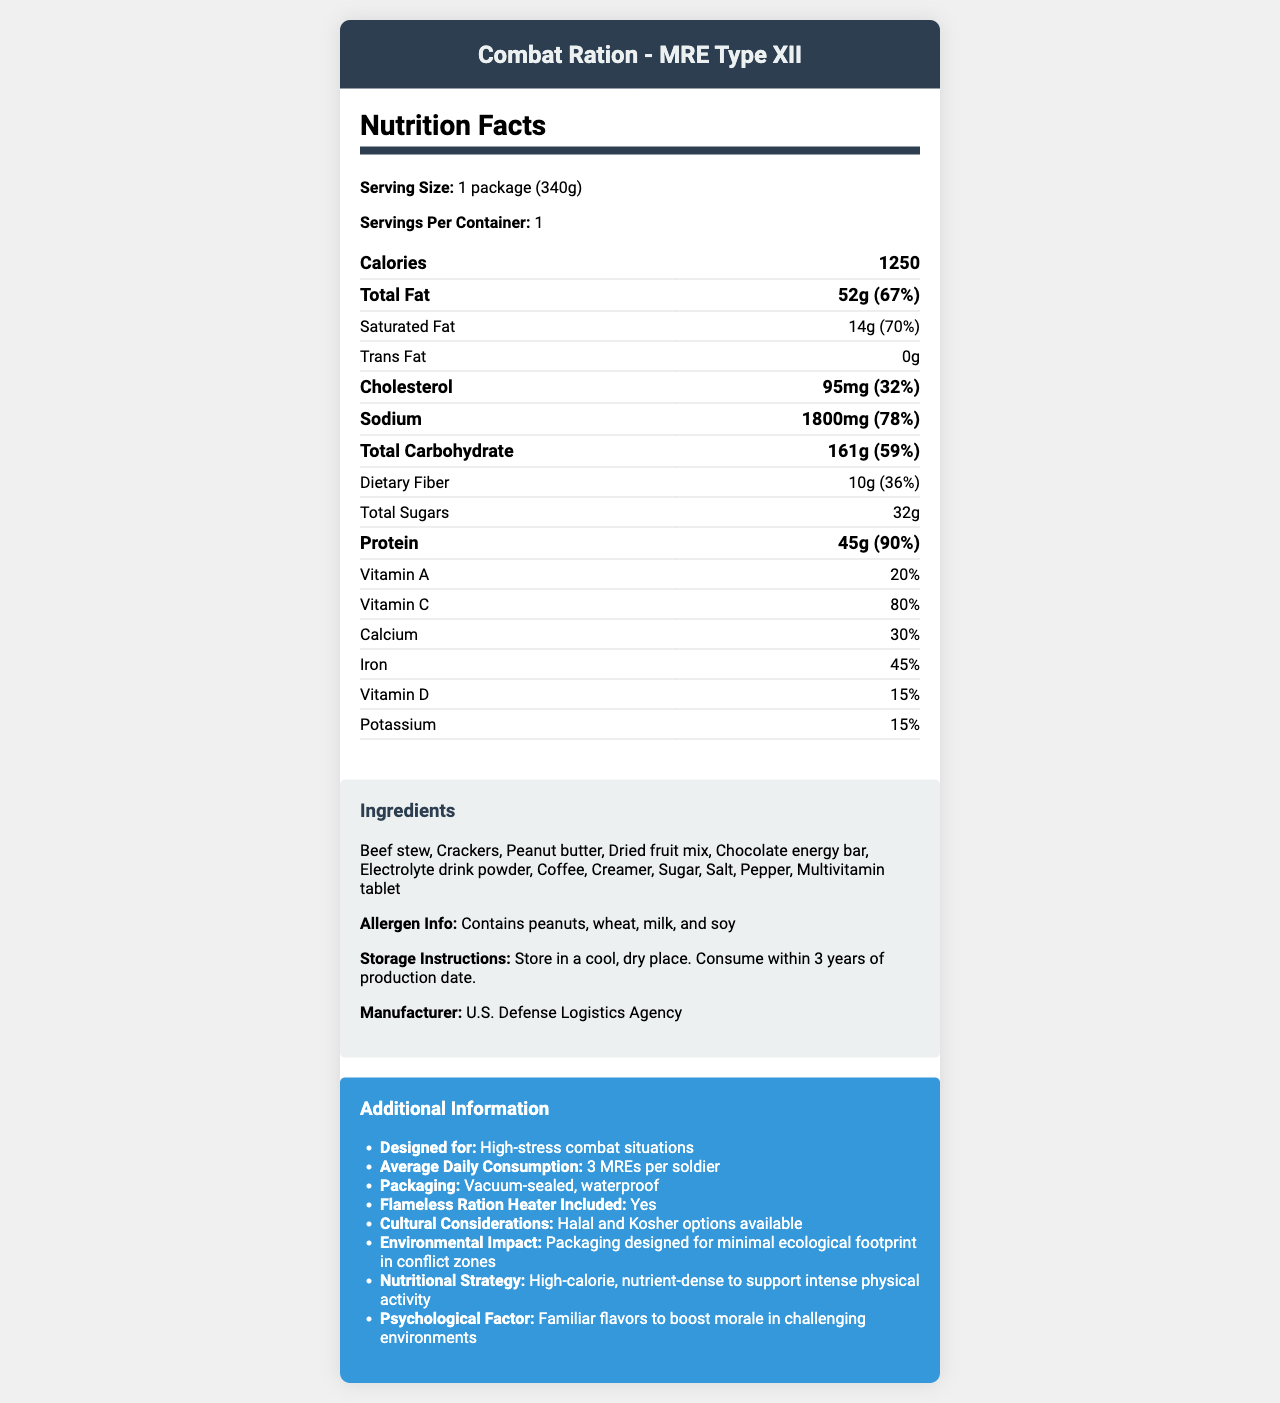what is the serving size for Combat Ration - MRE Type XII? The serving size is explicitly stated in the section titled "Nutrition Facts."
Answer: 1 package (340g) how much sodium is in one package? The sodium content is listed under the "Sodium" section, with both the amount and daily value percentage provided.
Answer: 1800mg what percentage of the daily value of Iron does one serving provide? The iron content and its daily value percentage are shown in the table under the "Nutrition Facts" section.
Answer: 45% how many calories does one package contain? The total calorie count is prominently displayed in the "Nutrition Facts" section.
Answer: 1250 what is the product name? The product name is clearly indicated at the top of the document.
Answer: Combat Ration - MRE Type XII what types of allergens are included in this product? The allergen information is provided in the "Ingredients" section.
Answer: Peanuts, wheat, milk, and soy which of the following is a listed ingredient? A. Almond butter B. Ham slices C. Peanut butter Under the "Ingredients" section, "Peanut butter" is listed.
Answer: C how should the product be stored? A. In a freezer B. In a warm, damp place C. In a cool, dry place D. At room temperature The storage instructions specify to store the package in a cool, dry place.
Answer: C is there a flameless ration heater included? The "Additional Information" section mentions that a flameless ration heater is included.
Answer: Yes summarize the document. The summary encapsulates the main content of the document including the nutritional breakdown, ingredients, and additional specifics provided.
Answer: The document is a detailed breakdown of the Nutrition Facts and other relevant information for "Combat Ration - MRE Type XII," a high-calorie, nutrient-dense military field ration. It includes nutritional values, a list of ingredients, allergen info, storage instructions, and additional attributes like flameless ration heater inclusion and cultural considerations. what is the daily value percentage for protein? The daily value percentage for protein is directly stated under the "Protein" section in the "Nutrition Facts."
Answer: 90% what is the potassium content percentage? The potassium content and its daily value percentage are listed in the "Nutrition Facts" section.
Answer: 15% what is the significance of familiar flavors in high-stress combat situations? The "Additional Information" section specifies that familiar flavors are intended to boost morale.
Answer: Boosts morale in challenging environments what does the product offer to ensure minimal ecological impact? The "Additional Information" section highlights that the packaging is designed to have a minimal ecological footprint.
Answer: Packaging designed for minimal ecological footprint in conflict zones is there information about the manufacturing date? The document does not provide details about the manufacturing date.
Answer: Not enough information 